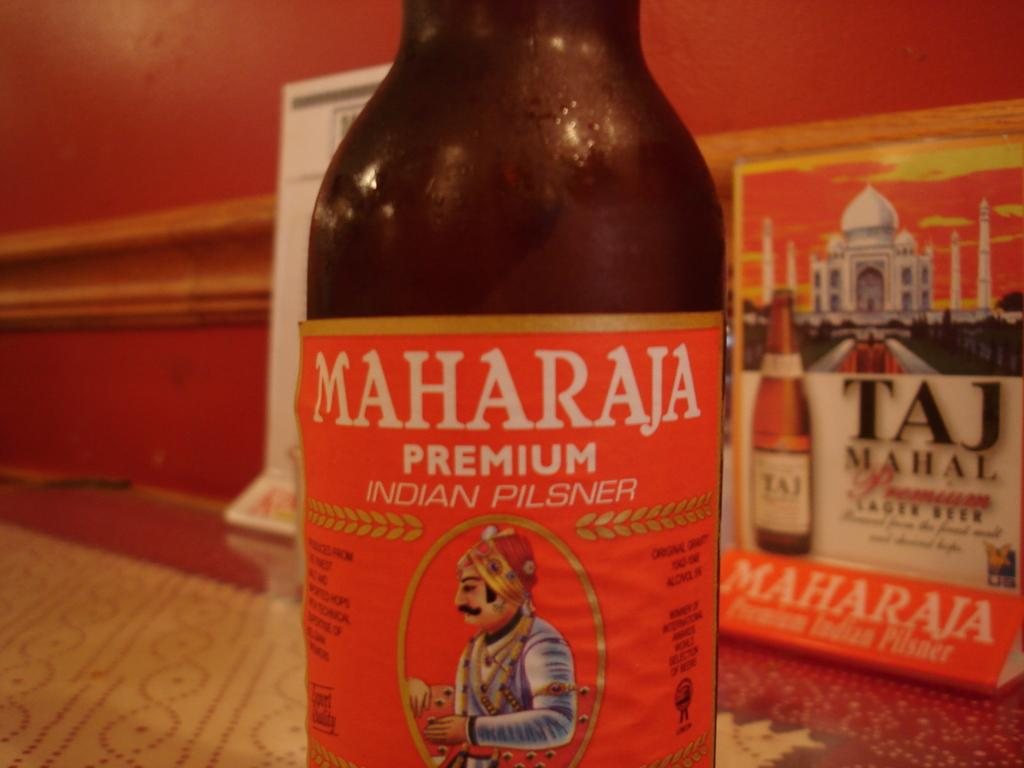<image>
Render a clear and concise summary of the photo. Maharaja Premium Indian Pilsner is the brand shown on this beer bottle. 